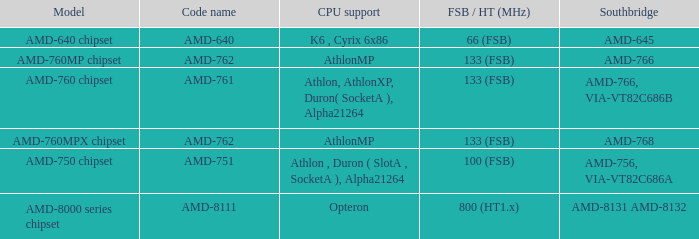What shows for Southbridge when the Model number is amd-640 chipset? AMD-645. 